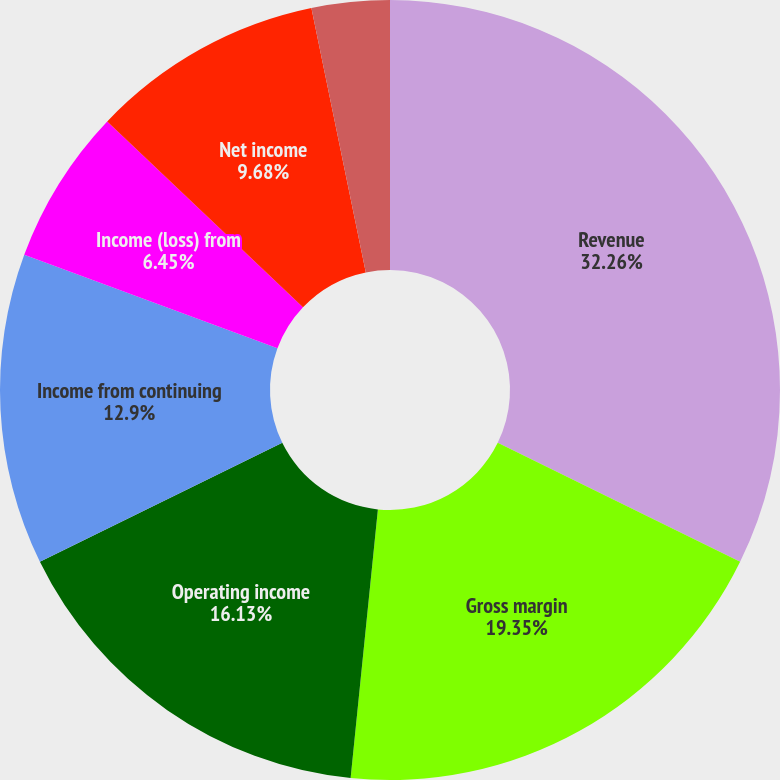Convert chart to OTSL. <chart><loc_0><loc_0><loc_500><loc_500><pie_chart><fcel>Revenue<fcel>Gross margin<fcel>Operating income<fcel>Income from continuing<fcel>Income (loss) from<fcel>Net income<fcel>Basic earnings per share from<fcel>Diluted earnings per share<nl><fcel>32.26%<fcel>19.35%<fcel>16.13%<fcel>12.9%<fcel>6.45%<fcel>9.68%<fcel>0.0%<fcel>3.23%<nl></chart> 